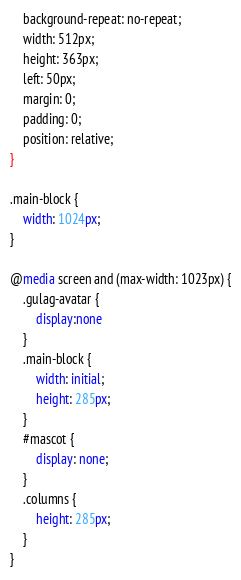Convert code to text. <code><loc_0><loc_0><loc_500><loc_500><_CSS_>    background-repeat: no-repeat;
    width: 512px;
    height: 363px;
    left: 50px;
    margin: 0;
    padding: 0;
    position: relative;
}

.main-block {
    width: 1024px;
}

@media screen and (max-width: 1023px) {
    .gulag-avatar {
        display:none
    }
    .main-block {
        width: initial;
        height: 285px;
    }
    #mascot {
        display: none;
    }
    .columns {
        height: 285px;
    }
}</code> 